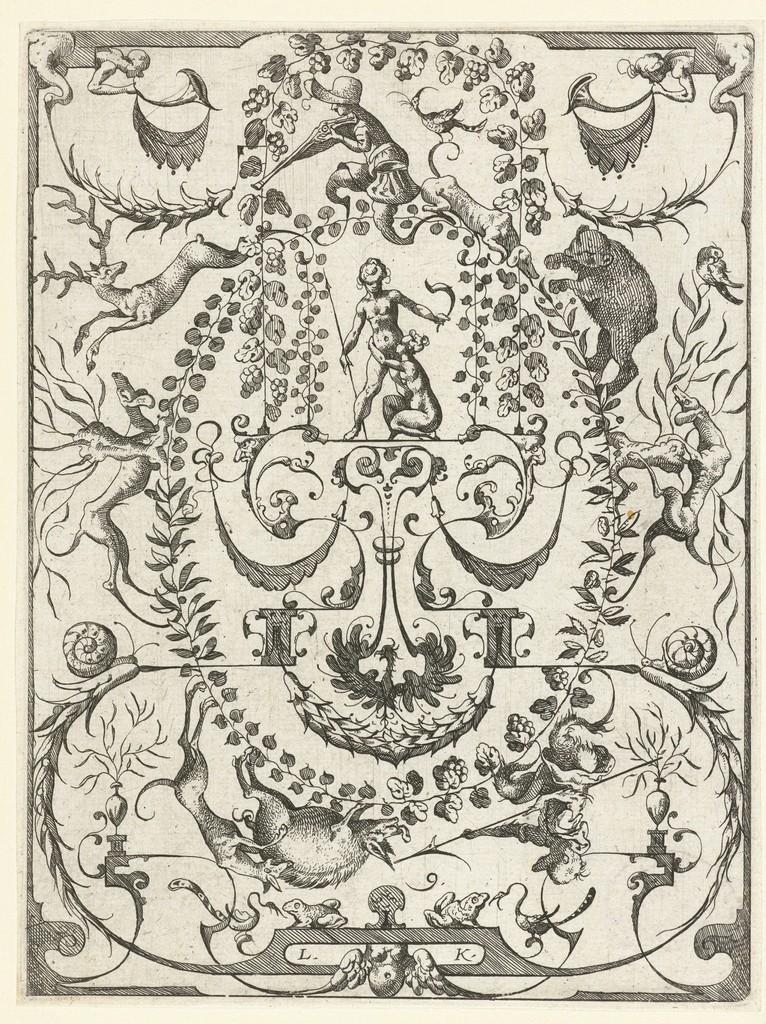In one or two sentences, can you explain what this image depicts? In the picture I can see the drawing of a person holding the pistol in the hands at the top of the picture. I can see the drawings of animals in the picture. I can see the drawing of a person holding the sword. 